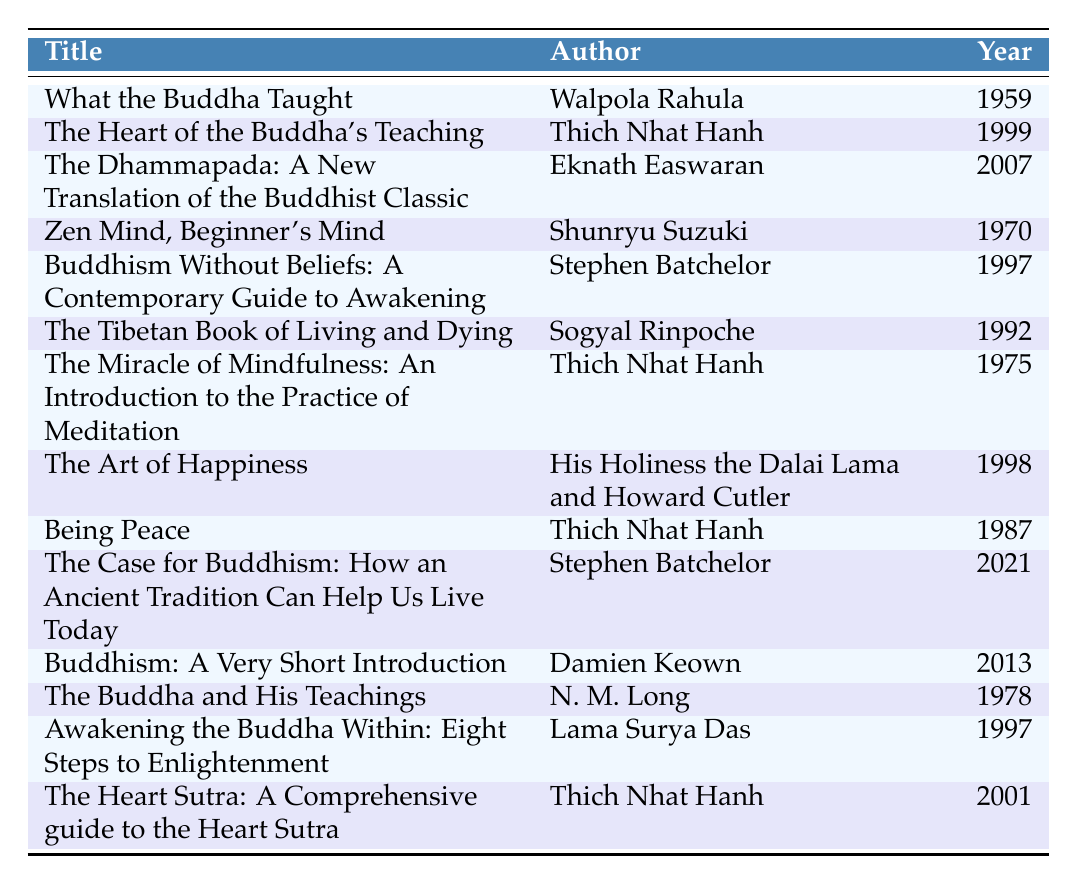What is the title of the book published in 2007? By looking at the table, I can see that the book titled "The Dhammapada: A New Translation of the Buddhist Classic" is listed under the year 2007.
Answer: The Dhammapada: A New Translation of the Buddhist Classic Who is the author of "Zen Mind, Beginner's Mind"? The table shows that "Zen Mind, Beginner's Mind" is authored by Shunryu Suzuki.
Answer: Shunryu Suzuki What year was "The Case for Buddhism" published? According to the table, "The Case for Buddhism: How an Ancient Tradition Can Help Us Live Today" was published in 2021.
Answer: 2021 How many books were published after 1990? By counting the entries in the publication year column that are above 1990, we find that there are 7 books: "The Tibetan Book of Living and Dying" (1992), "The Art of Happiness" (1998), "The Heart of the Buddha's Teaching" (1999), "Awakening the Buddha Within" (1997), "The Dhammapada" (2007), "Buddhism: A Very Short Introduction" (2013), and "The Case for Buddhism" (2021).
Answer: 7 Is "What the Buddha Taught" the earliest publication on the list? Yes, by checking the publication years listed, I see that "What the Buddha Taught" was published in 1959, which is before all other entries.
Answer: Yes Which author has published the most books on this list? I notice that Thich Nhat Hanh appears three times in the author column for the books: "The Heart of the Buddha's Teaching," "The Miracle of Mindfulness," and "Being Peace." This is more than any other author listed.
Answer: Thich Nhat Hanh What is the average publication year of the books by Stephen Batchelor? The books written by Stephen Batchelor are "Buddhism Without Beliefs" (1997) and "The Case for Buddhism" (2021). To find the average, we sum 1997 + 2021 = 4018 and then divide by 2, resulting in an average year of 2009.5. Rounding, the average is 2009.
Answer: 2009 Which book was published closest to the year 2000? Evaluating the publication years, "The Heart of the Buddha's Teaching" (1999) is one year before 2000, while "The Heart Sutra" is from 2001, making the former closest.
Answer: The Heart of the Buddha's Teaching List all books authored by Thich Nhat Hanh. In the table, I see that Thich Nhat Hanh is the author of "The Heart of the Buddha's Teaching," "The Miracle of Mindfulness," "Being Peace," and "The Heart Sutra." Thus, the list is: "The Heart of the Buddha's Teaching," "The Miracle of Mindfulness," "Being Peace," and "The Heart Sutra."
Answer: The Heart of the Buddha's Teaching, The Miracle of Mindfulness, Being Peace, The Heart Sutra 